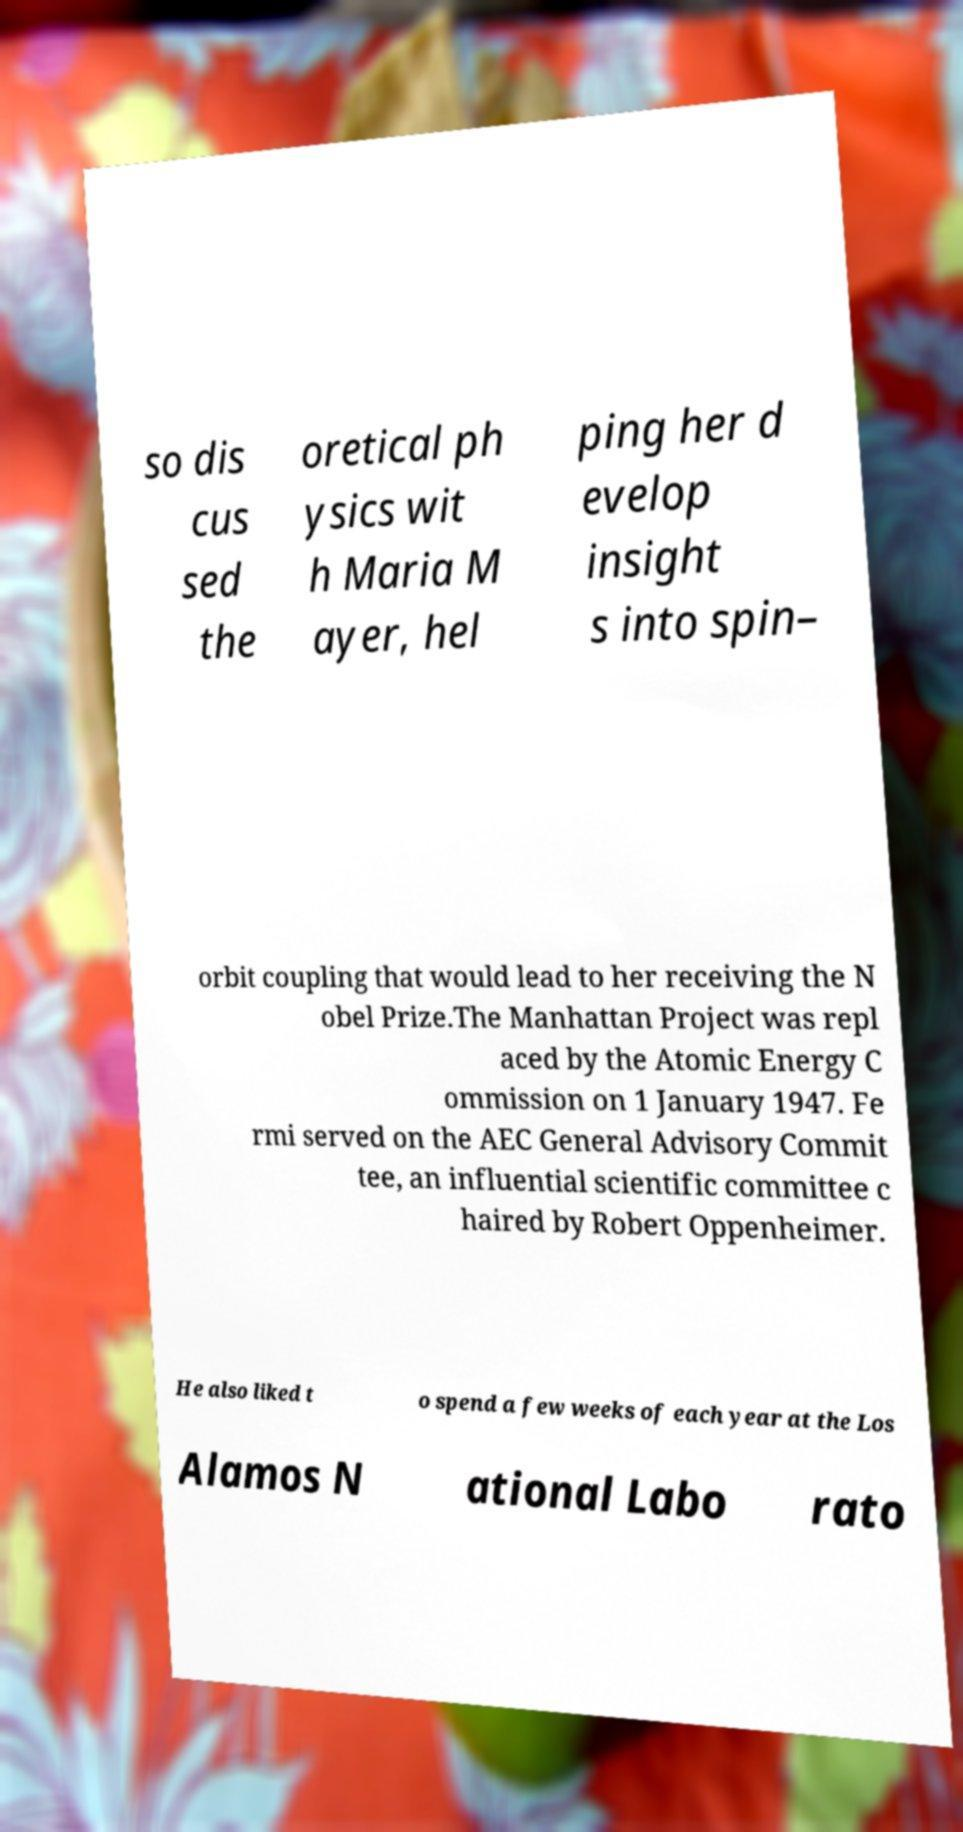Can you accurately transcribe the text from the provided image for me? so dis cus sed the oretical ph ysics wit h Maria M ayer, hel ping her d evelop insight s into spin– orbit coupling that would lead to her receiving the N obel Prize.The Manhattan Project was repl aced by the Atomic Energy C ommission on 1 January 1947. Fe rmi served on the AEC General Advisory Commit tee, an influential scientific committee c haired by Robert Oppenheimer. He also liked t o spend a few weeks of each year at the Los Alamos N ational Labo rato 